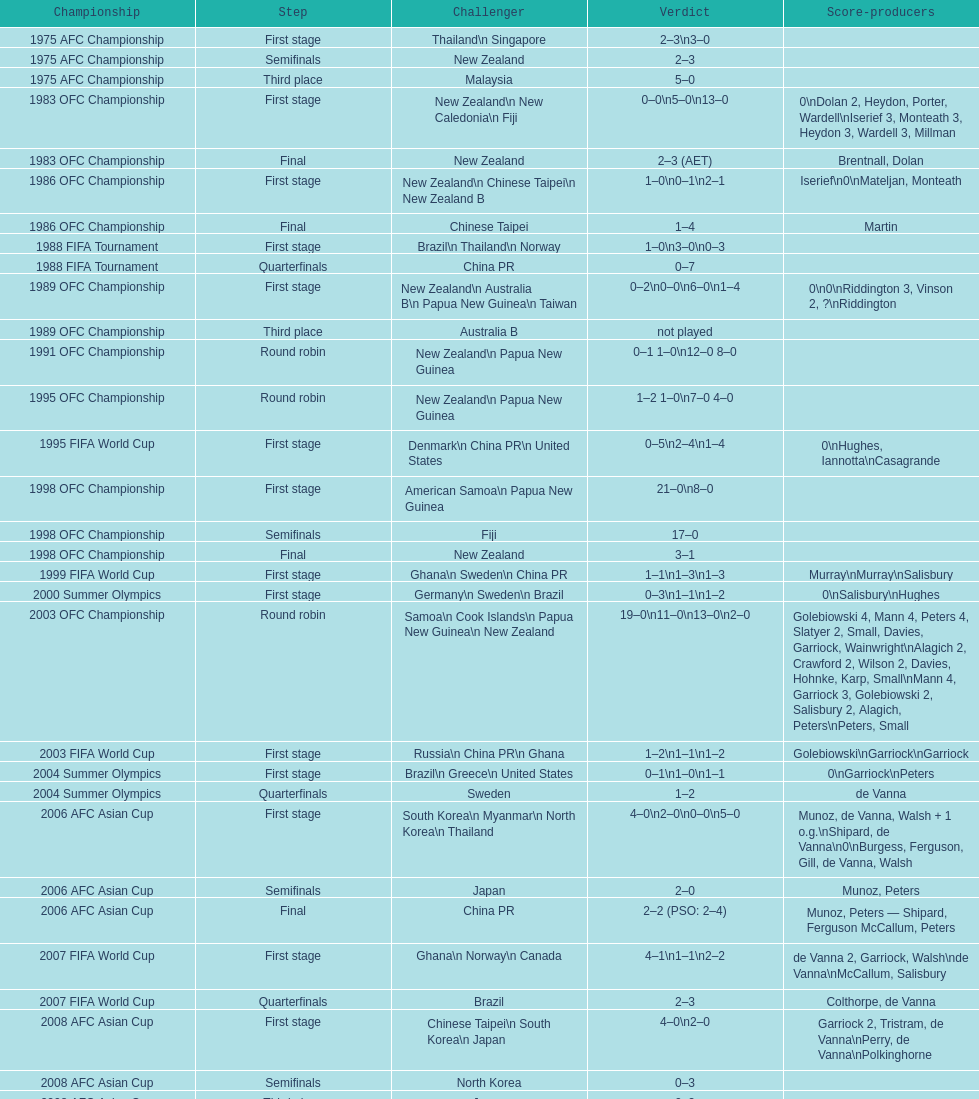How many players scored during the 1983 ofc championship competition? 9. 